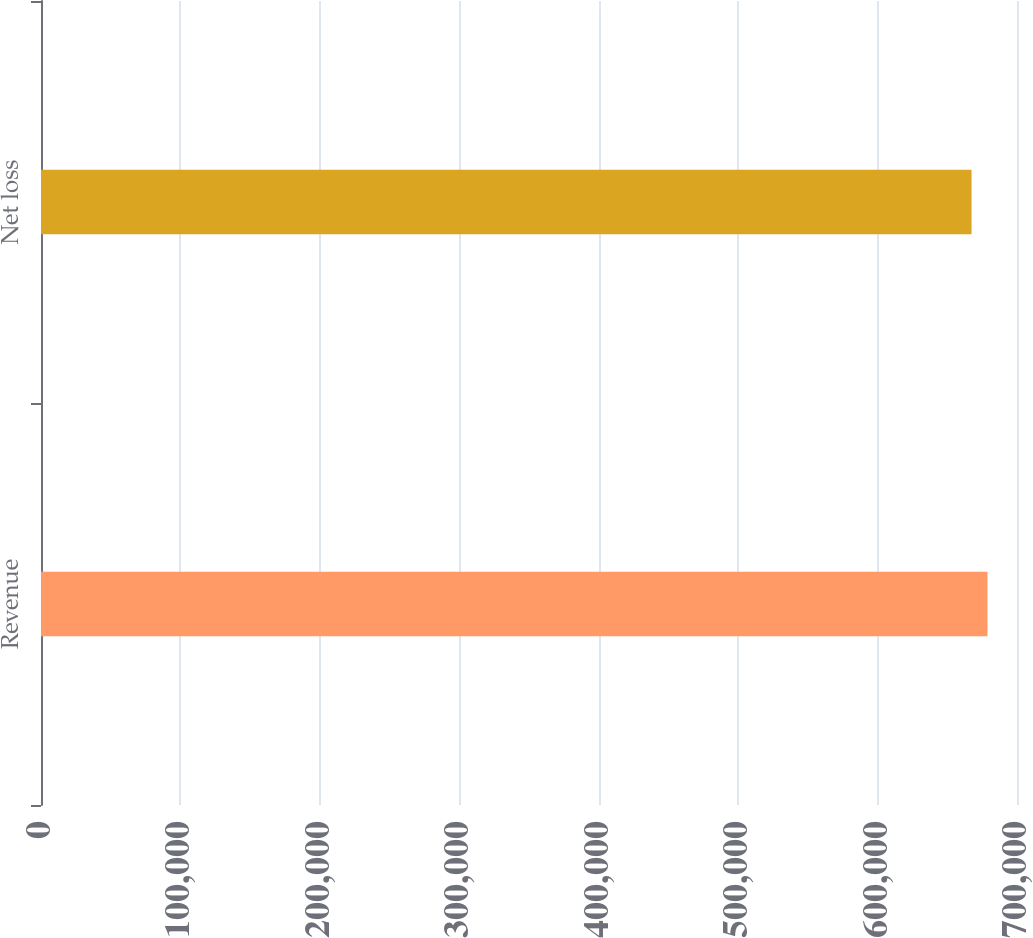<chart> <loc_0><loc_0><loc_500><loc_500><bar_chart><fcel>Revenue<fcel>Net loss<nl><fcel>678838<fcel>667404<nl></chart> 